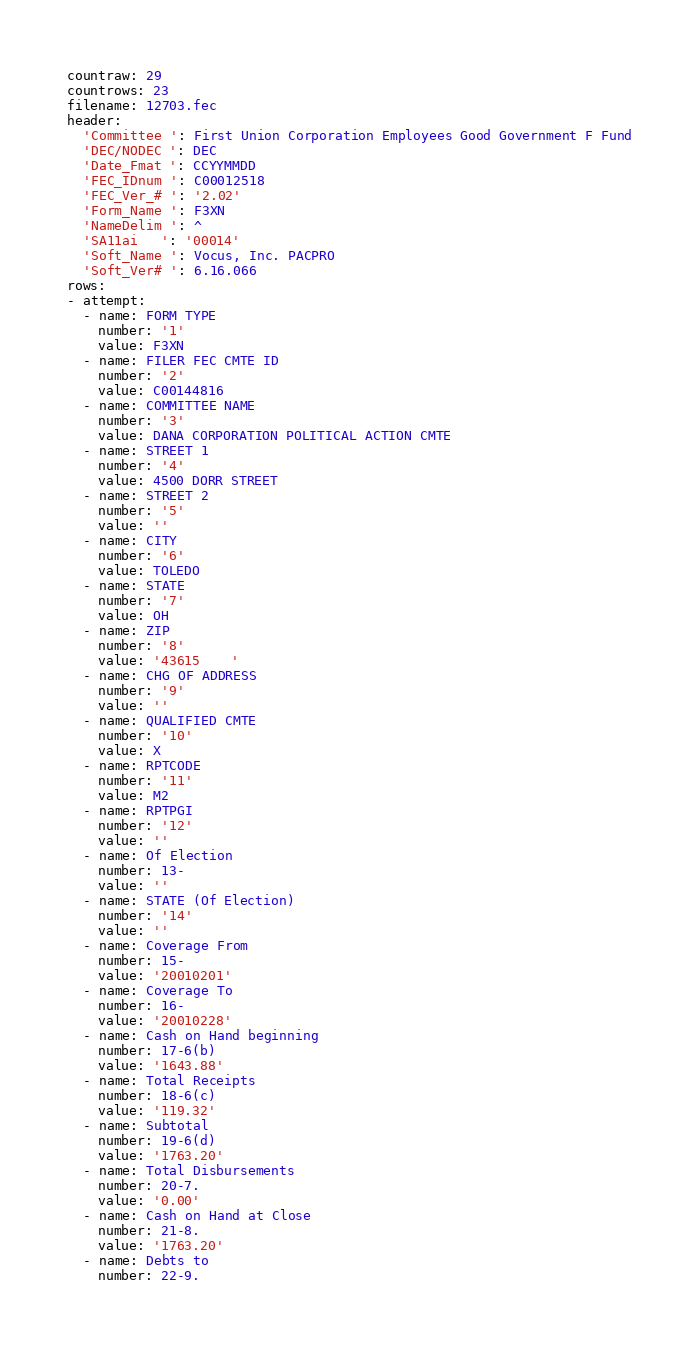<code> <loc_0><loc_0><loc_500><loc_500><_YAML_>countraw: 29
countrows: 23
filename: 12703.fec
header:
  'Committee ': First Union Corporation Employees Good Government F Fund
  'DEC/NODEC ': DEC
  'Date_Fmat ': CCYYMMDD
  'FEC_IDnum ': C00012518
  'FEC_Ver_# ': '2.02'
  'Form_Name ': F3XN
  'NameDelim ': ^
  'SA11ai   ': '00014'
  'Soft_Name ': Vocus, Inc. PACPRO
  'Soft_Ver# ': 6.16.066
rows:
- attempt:
  - name: FORM TYPE
    number: '1'
    value: F3XN
  - name: FILER FEC CMTE ID
    number: '2'
    value: C00144816
  - name: COMMITTEE NAME
    number: '3'
    value: DANA CORPORATION POLITICAL ACTION CMTE
  - name: STREET 1
    number: '4'
    value: 4500 DORR STREET
  - name: STREET 2
    number: '5'
    value: ''
  - name: CITY
    number: '6'
    value: TOLEDO
  - name: STATE
    number: '7'
    value: OH
  - name: ZIP
    number: '8'
    value: '43615    '
  - name: CHG OF ADDRESS
    number: '9'
    value: ''
  - name: QUALIFIED CMTE
    number: '10'
    value: X
  - name: RPTCODE
    number: '11'
    value: M2
  - name: RPTPGI
    number: '12'
    value: ''
  - name: Of Election
    number: 13-
    value: ''
  - name: STATE (Of Election)
    number: '14'
    value: ''
  - name: Coverage From
    number: 15-
    value: '20010201'
  - name: Coverage To
    number: 16-
    value: '20010228'
  - name: Cash on Hand beginning
    number: 17-6(b)
    value: '1643.88'
  - name: Total Receipts
    number: 18-6(c)
    value: '119.32'
  - name: Subtotal
    number: 19-6(d)
    value: '1763.20'
  - name: Total Disbursements
    number: 20-7.
    value: '0.00'
  - name: Cash on Hand at Close
    number: 21-8.
    value: '1763.20'
  - name: Debts to
    number: 22-9.</code> 